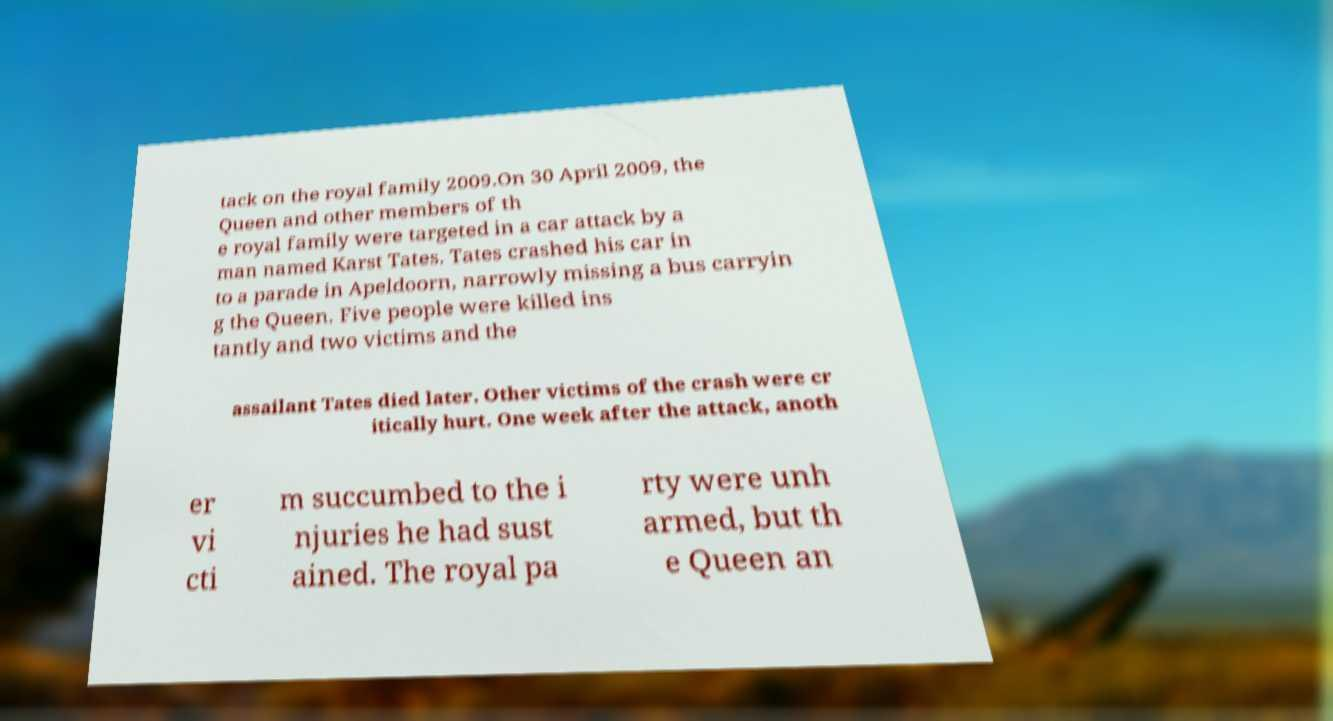Please identify and transcribe the text found in this image. tack on the royal family 2009.On 30 April 2009, the Queen and other members of th e royal family were targeted in a car attack by a man named Karst Tates. Tates crashed his car in to a parade in Apeldoorn, narrowly missing a bus carryin g the Queen. Five people were killed ins tantly and two victims and the assailant Tates died later. Other victims of the crash were cr itically hurt. One week after the attack, anoth er vi cti m succumbed to the i njuries he had sust ained. The royal pa rty were unh armed, but th e Queen an 